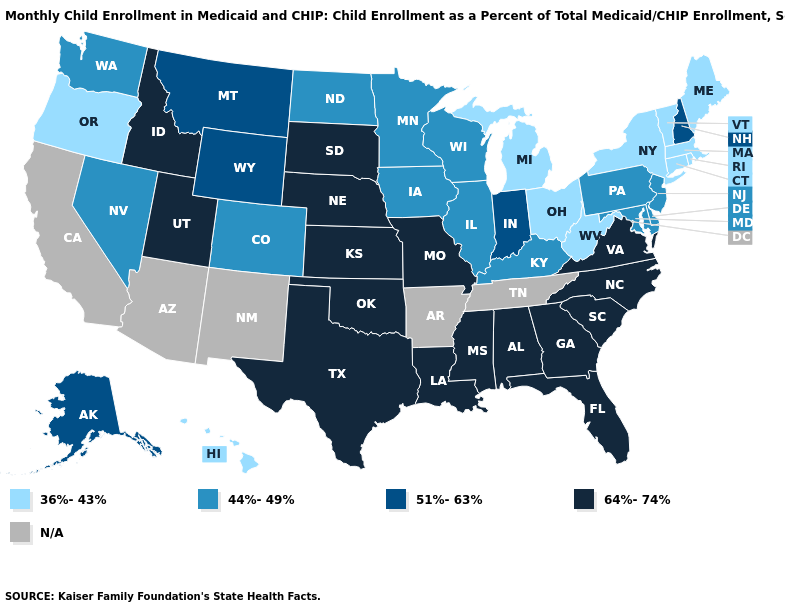What is the highest value in the MidWest ?
Quick response, please. 64%-74%. Among the states that border Iowa , which have the lowest value?
Give a very brief answer. Illinois, Minnesota, Wisconsin. What is the lowest value in the USA?
Write a very short answer. 36%-43%. Name the states that have a value in the range 51%-63%?
Write a very short answer. Alaska, Indiana, Montana, New Hampshire, Wyoming. What is the value of New York?
Short answer required. 36%-43%. Does Indiana have the highest value in the USA?
Short answer required. No. Is the legend a continuous bar?
Write a very short answer. No. What is the lowest value in the South?
Keep it brief. 36%-43%. What is the value of Nebraska?
Keep it brief. 64%-74%. What is the value of Alabama?
Concise answer only. 64%-74%. Among the states that border Massachusetts , which have the lowest value?
Give a very brief answer. Connecticut, New York, Rhode Island, Vermont. Name the states that have a value in the range 64%-74%?
Be succinct. Alabama, Florida, Georgia, Idaho, Kansas, Louisiana, Mississippi, Missouri, Nebraska, North Carolina, Oklahoma, South Carolina, South Dakota, Texas, Utah, Virginia. 